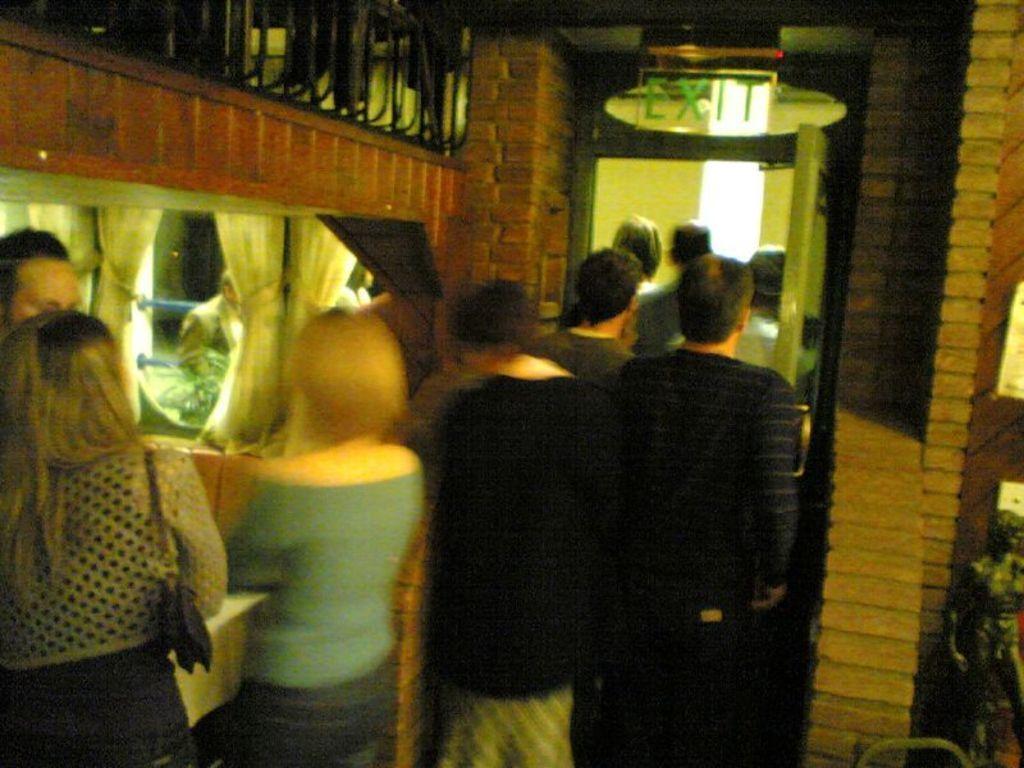In one or two sentences, can you explain what this image depicts? In this picture there is a woman who is wearing green t-shirt and jeans, beside her i can see another woman who is wearing black dress and holding a bag, beside here there is a man. Near to door i can see many peoples were standing, beside them there is a brick wall. At the top i can see the exit sign board. In the top left corner there is a fencing. In the bottom left there is a statue near to the board. 